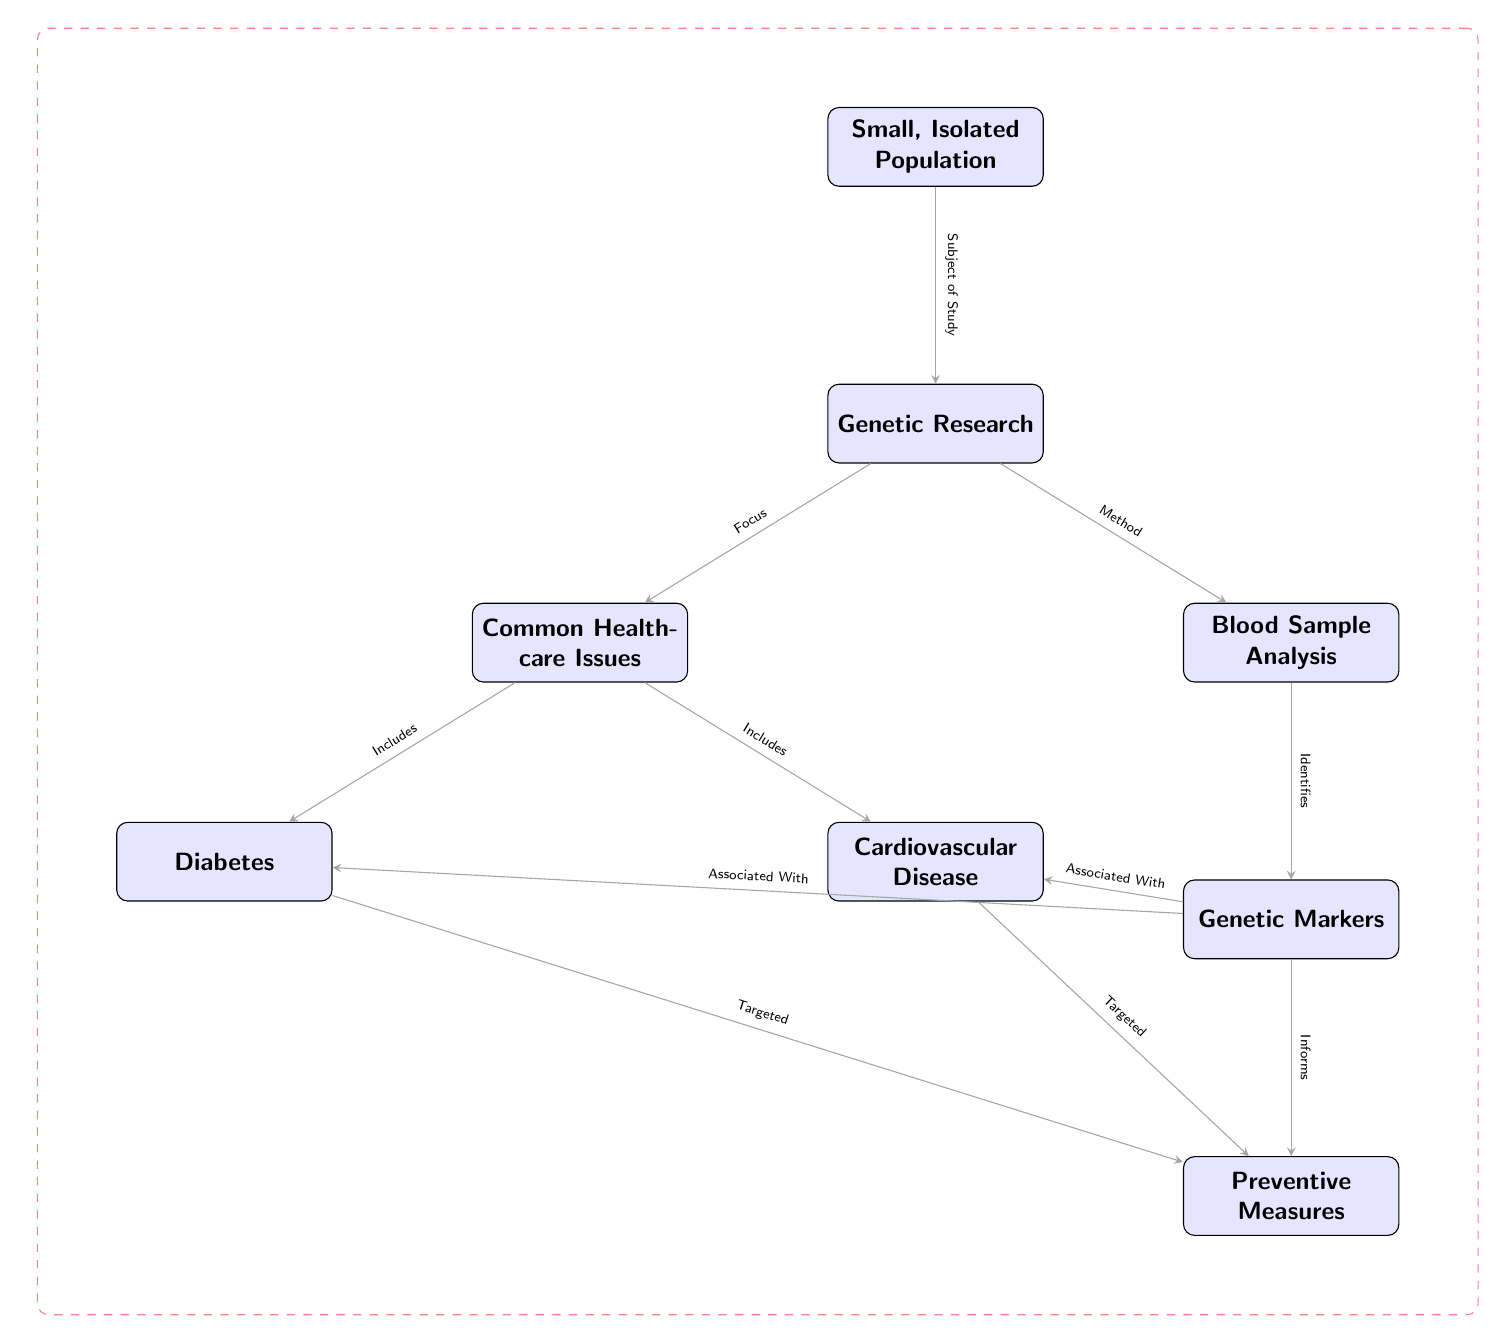What is the subject of study in the diagram? The diagram clearly states that the subject of study is the "Small, Isolated Population" that encompasses all the research activities.
Answer: Small, Isolated Population How many common healthcare issues are included in the diagram? The diagram lists two common healthcare issues: Diabetes and Cardiovascular Disease. Thus, counting the nodes that represent these issues gives a total of two.
Answer: 2 What type of analysis is mentioned in the research process? According to the diagram, the type of analysis conducted as part of the genetic research is "Blood Sample Analysis." This is explicitly stated in the connection between Genetic Research and Blood Sample Analysis.
Answer: Blood Sample Analysis Which healthcare issue is targeted for preventive measures according to the genetic markers? Based on the diagram, both Diabetes and Cardiovascular Disease are associated with genetic markers and both are indicated as being targeted for preventive measures. Since the question asks for one of them, either can be valid.
Answer: Diabetes What flow of information links genetic markers to preventive measures? The diagram shows that genetic markers are associated with both Diabetes and Cardiovascular Disease, and also informs the preventive measures established for these issues. Thus, the flow of information is from Genetic Markers to Preventive Measures via these associations.
Answer: Genetic Markers What identifies genetic markers in the study? The diagram states that "Blood Sample Analysis" is the method used to identify genetic markers in the population, drawing a direct link between Blood Sample Analysis and Genetic Markers.
Answer: Blood Sample Analysis What are the two main focuses of the genetic research? The two main focuses highlighted in the diagram under Common Healthcare Issues are Diabetes and Cardiovascular Disease, emphasizing the issues being investigated through genetic research.
Answer: Diabetes, Cardiovascular Disease How does genetic research inform healthcare provisions in the small population? The relationship shown in the diagram indicates that the genetic research through blood analysis identifies genetic markers, which in turn informs the development of preventive measures for the healthcare issues identified. Thus, the flow culminates in identifying tailored healthcare provisions.
Answer: Preventive Measures 